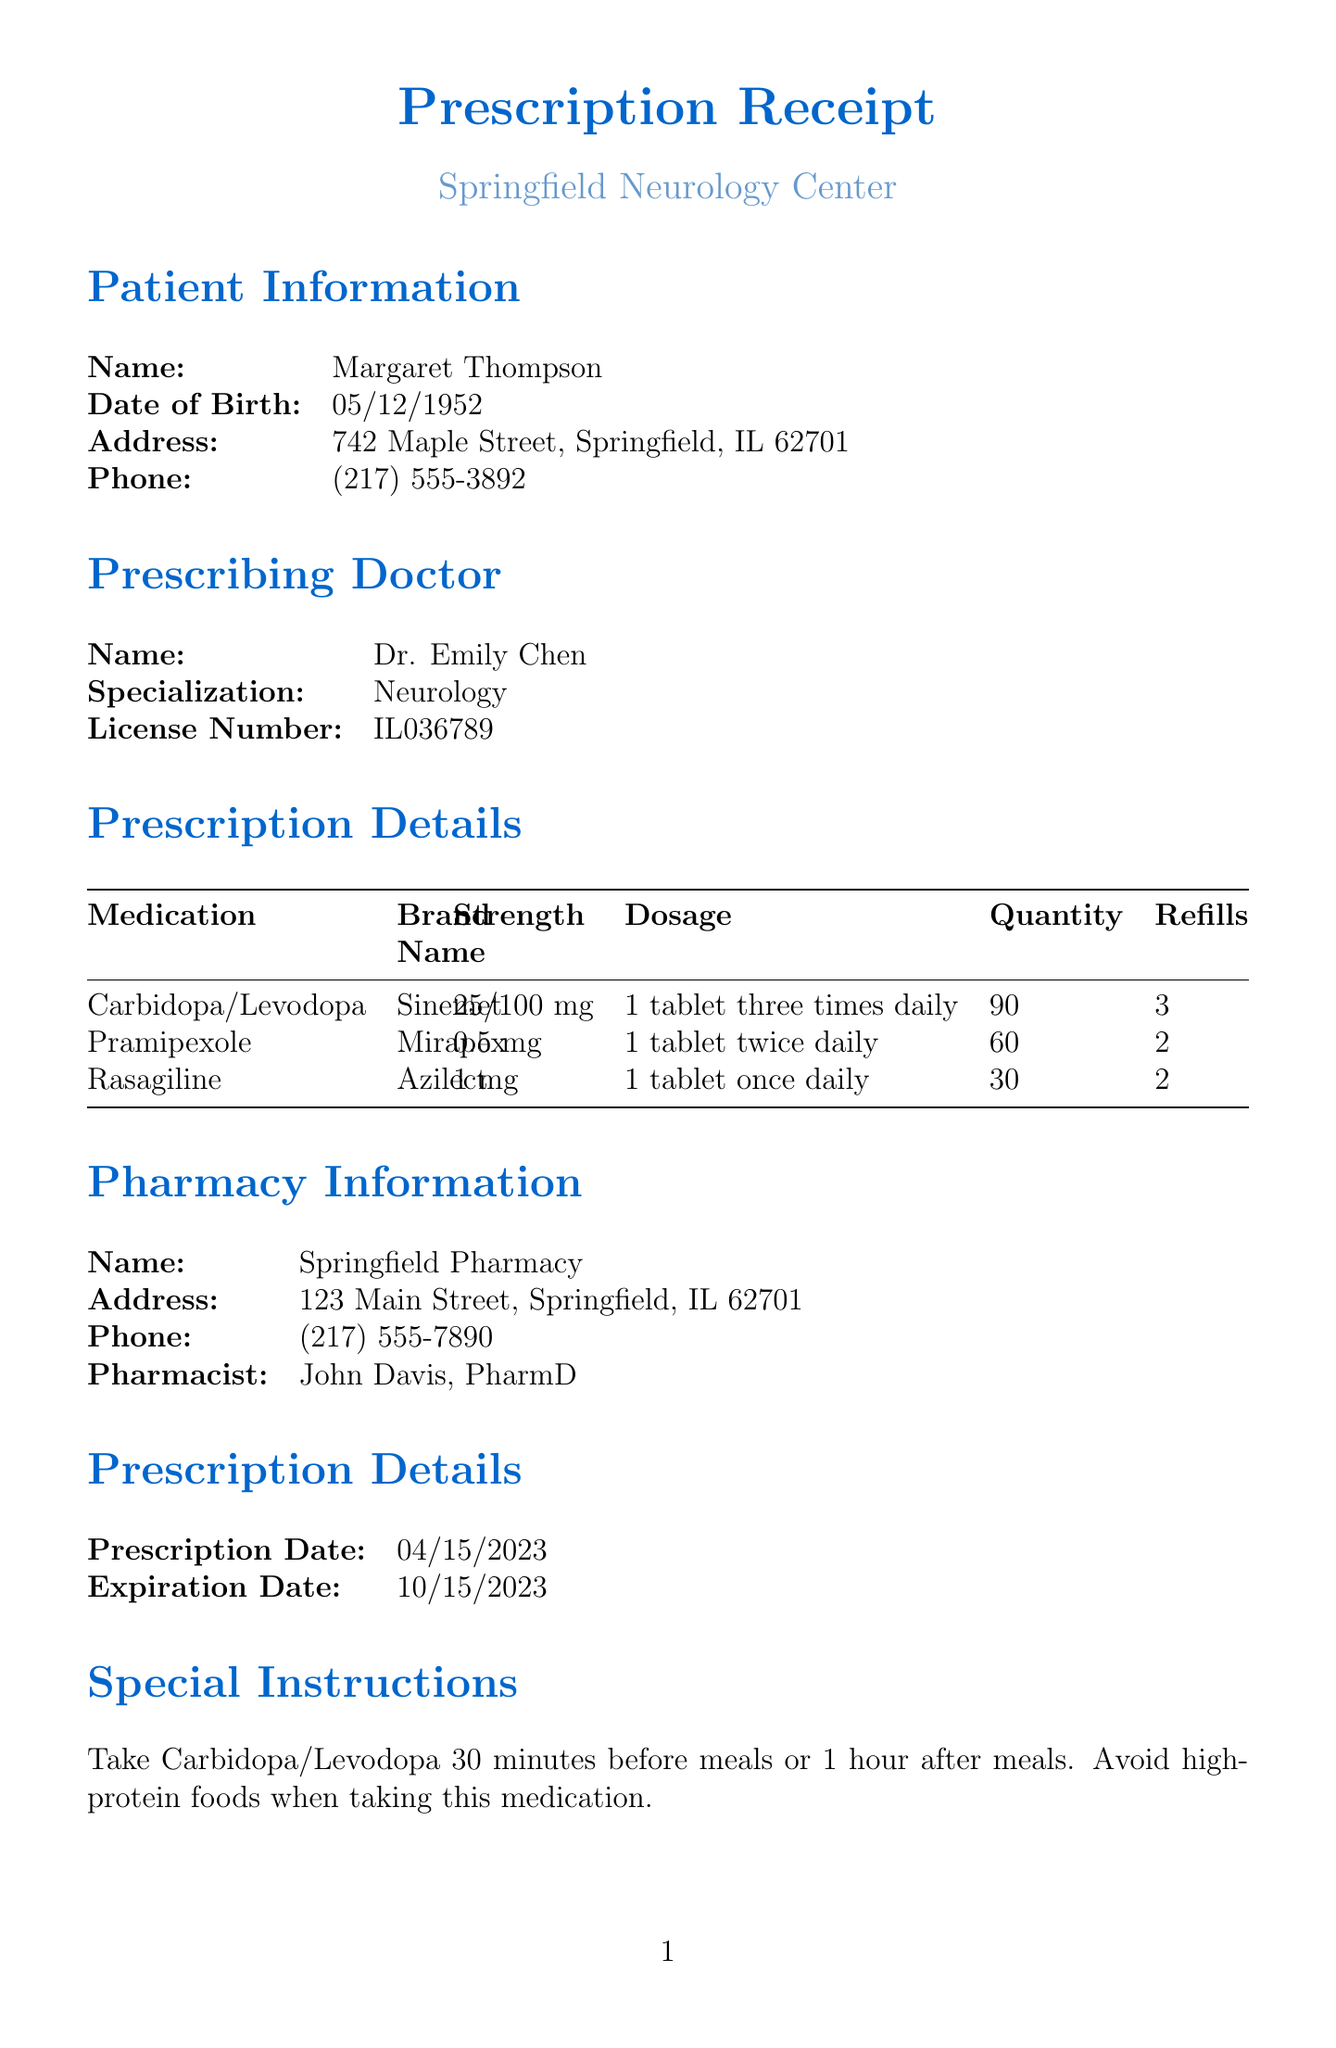what is the name of the patient? The patient's name is listed in the patient information section of the document.
Answer: Margaret Thompson what medication is prescribed for stronger muscle control? The prescription details list different medications, with the specific one for muscle control mentioned there.
Answer: Carbidopa/Levodopa how many refills are available for Pramipexole? The prescription details provide the number of refills available for each medication.
Answer: 2 what is the strength of Rasagiline? The strength of each medication is indicated in the prescription details section.
Answer: 1 mg when is the follow-up appointment scheduled? The follow-up appointment date is explicitly stated towards the end of the document.
Answer: 07/15/2023 who is the prescribing doctor? The prescribing doctor's name is found in the prescribing doctor section of the document.
Answer: Dr. Emily Chen what are the side effects to watch for? The side effects listed in the document are available in a specific section for monitoring.
Answer: Nausea, Dizziness, Orthostatic hypotension, Dyskinesia, Hallucinations what instructions are provided for taking Carbidopa/Levodopa? Special instructions on how to take Carbidopa/Levodopa are detailed in the corresponding section.
Answer: Take 30 minutes before meals or 1 hour after meals. Avoid high-protein foods where is the pharmacy located? The pharmacy's address is provided in the pharmacy information section of the document.
Answer: 123 Main Street, Springfield, IL 62701 